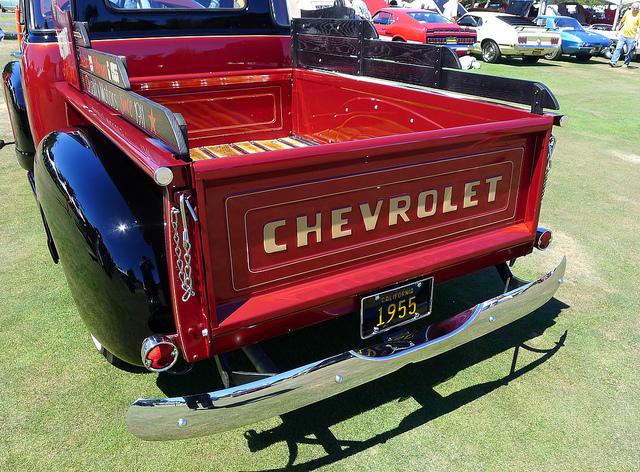What are the chains used for on the back of the truck?
Concise answer only. To pull object. Who is the truck manufacturer?
Give a very brief answer. Chevrolet. Is this a big truck?
Give a very brief answer. Yes. 